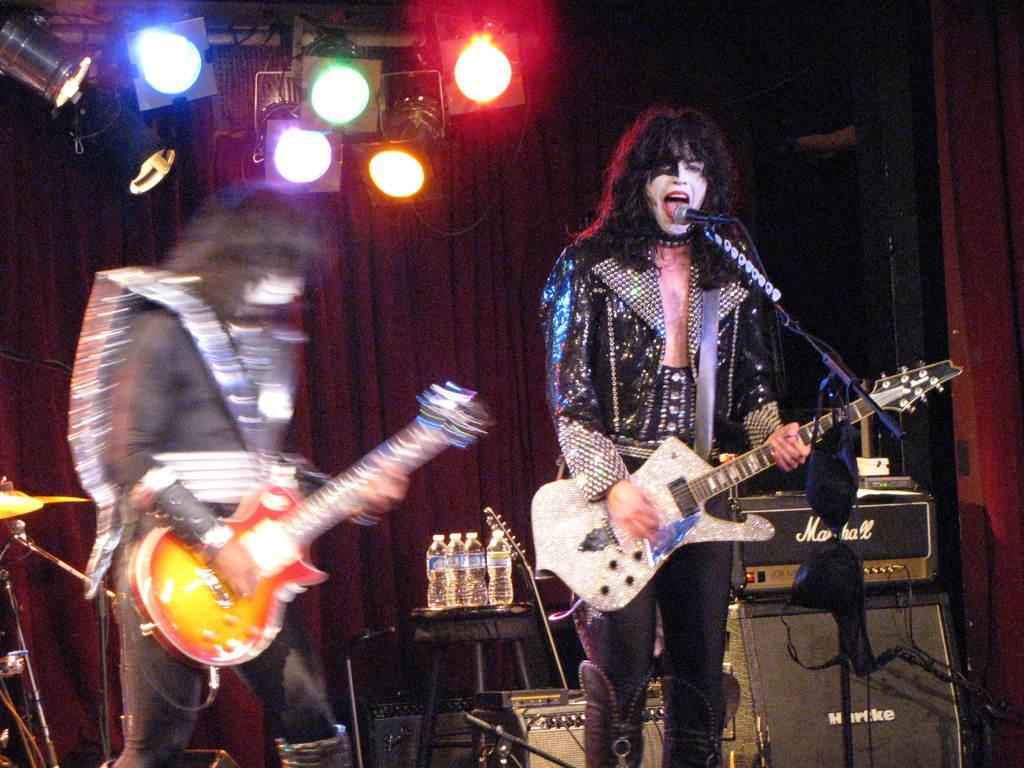Describe this image in one or two sentences. In this picture there are two people playing a guitar. There is a mic, some lights, bottles on the table and other musical instruments at the background. 